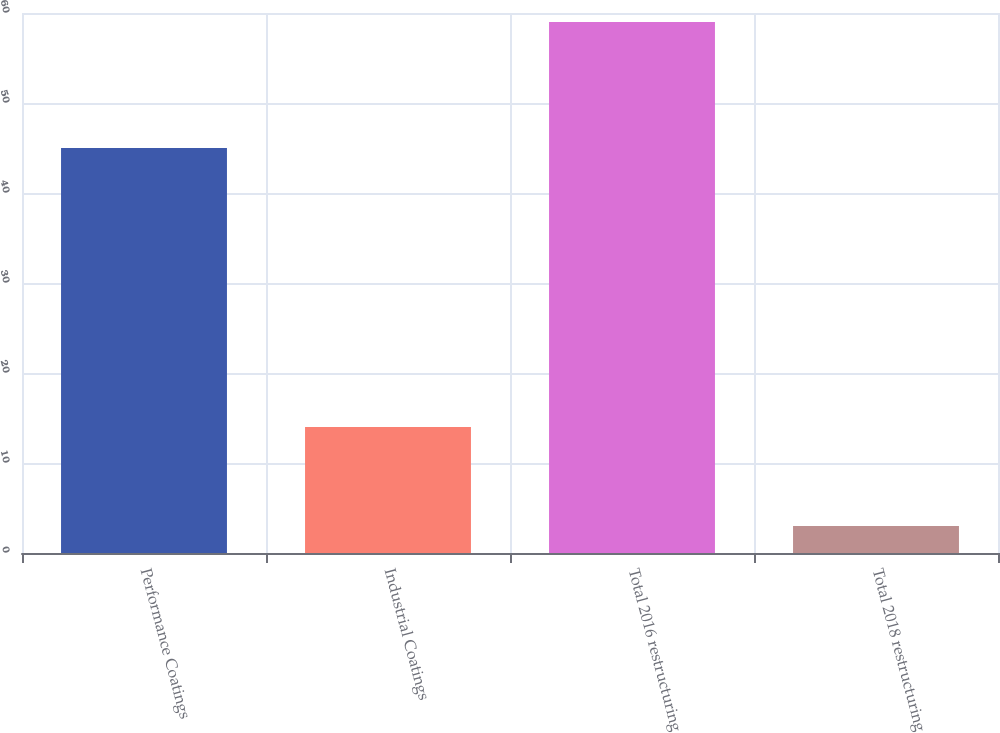Convert chart. <chart><loc_0><loc_0><loc_500><loc_500><bar_chart><fcel>Performance Coatings<fcel>Industrial Coatings<fcel>Total 2016 restructuring<fcel>Total 2018 restructuring<nl><fcel>45<fcel>14<fcel>59<fcel>3<nl></chart> 